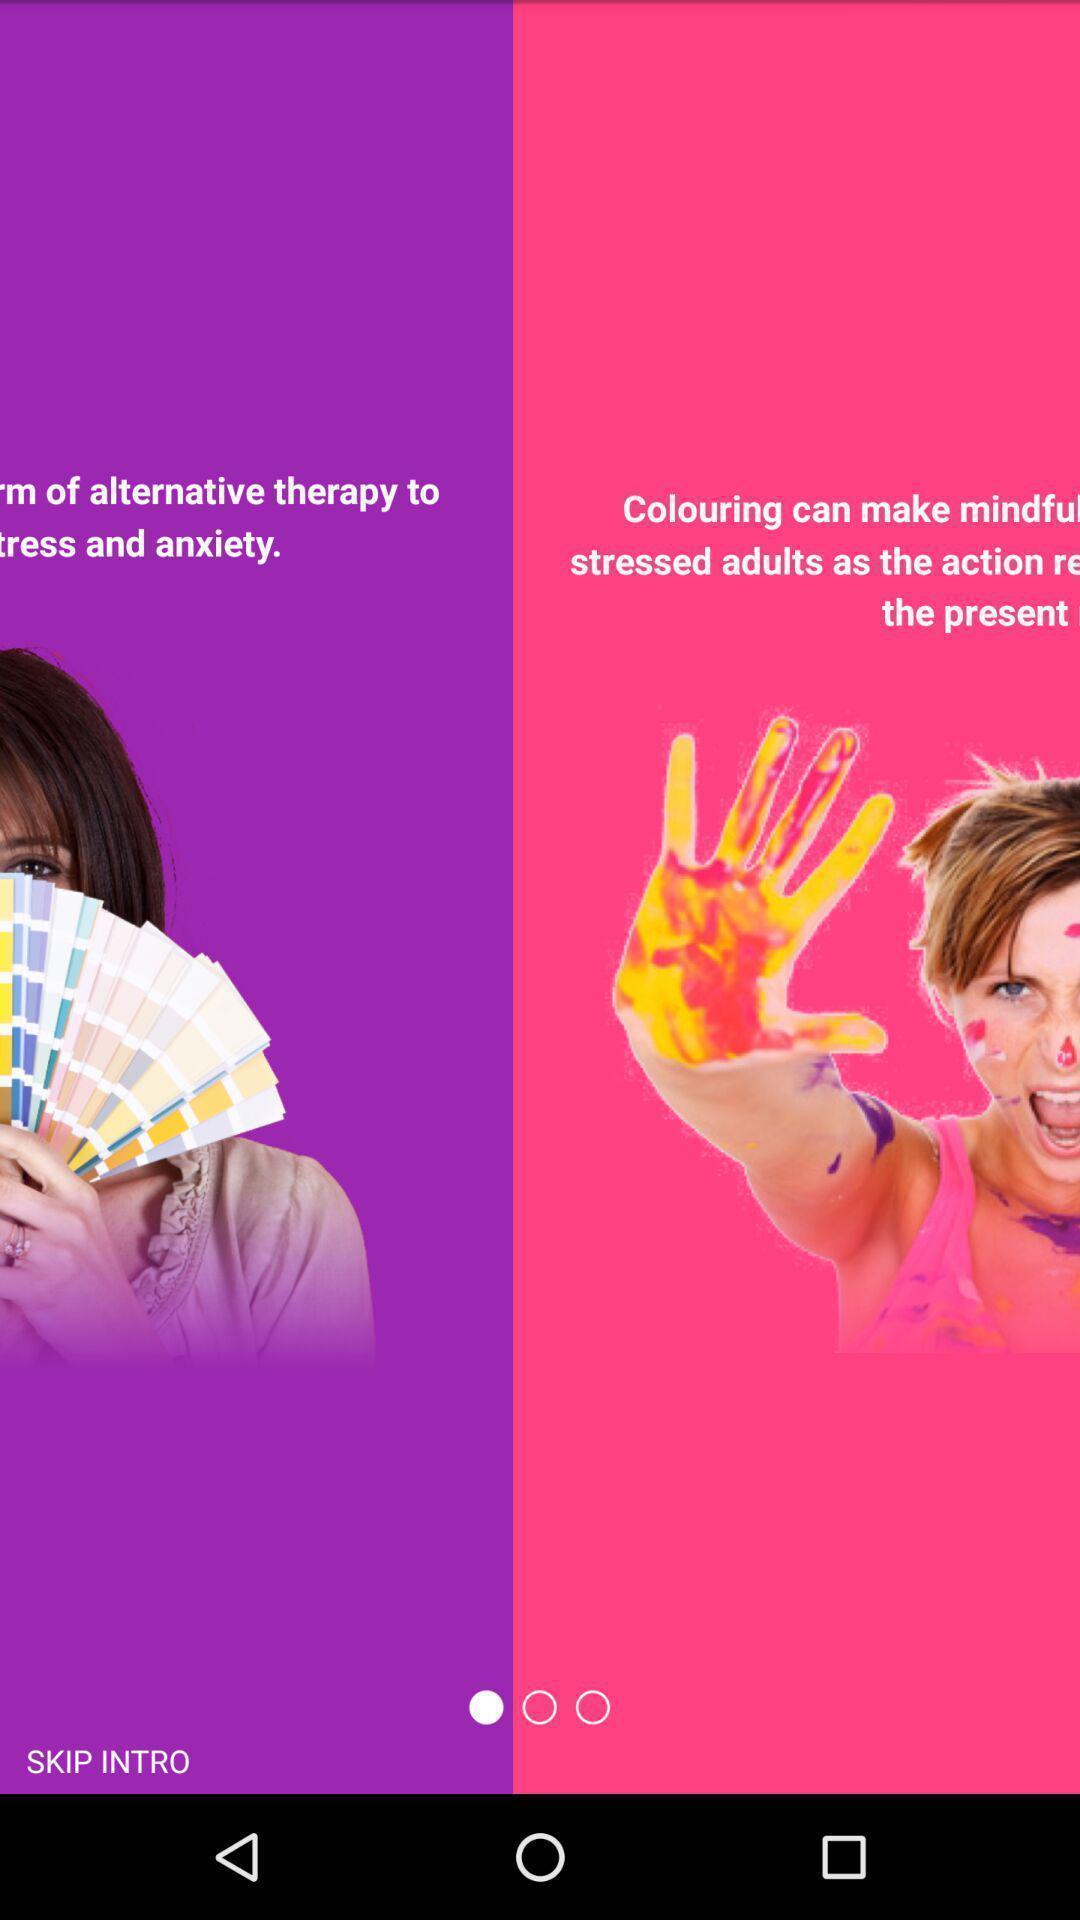Describe the visual elements of this screenshot. Screen displaying intro about the application. 